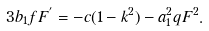Convert formula to latex. <formula><loc_0><loc_0><loc_500><loc_500>3 b _ { 1 } f F ^ { ^ { \prime } } = - c ( 1 - k ^ { 2 } ) - a _ { 1 } ^ { 2 } q F ^ { 2 } .</formula> 